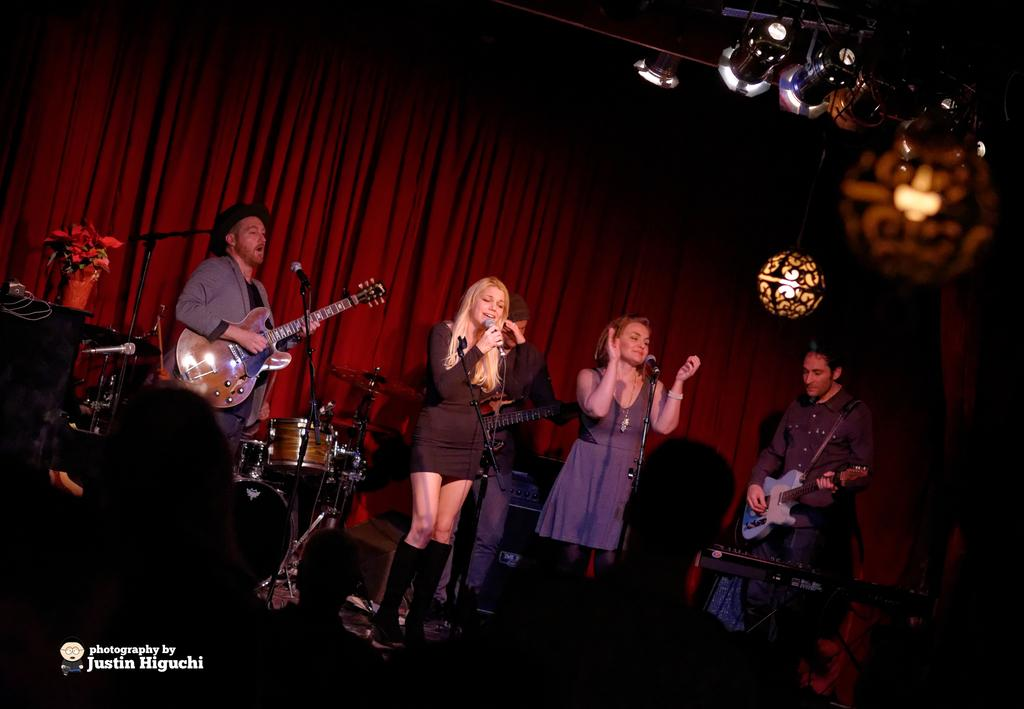Who can be seen in the image? There are people in the image. What are some of the people doing in the image? Some people are standing in front of a mic, and some are holding guitars. What can be seen in the background of the image? There is a curtain in the background of the image. What type of pie is being served to the boy in the image? There is no boy or pie present in the image. 